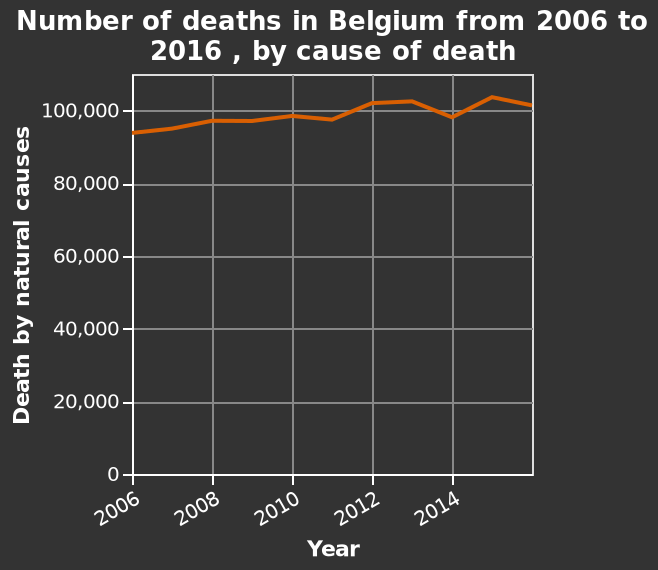<image>
Offer a thorough analysis of the image. There are approximately 100,000 deaths by natural causes in a typical year in Belgium. There appears to be a slightly increasing trend of deaths by natural causes in Belgium from 2006 to 2016. The highest number of deaths by natural causes in the years given was in 2015. The lowest number of deaths by natural causes in the years given was in 2006. Did deaths by natural causes decrease in 2010? The information provided does not mention whether deaths by natural causes decreased in 2010. What is the variable measured along the x-axis? The variable measured along the x-axis is the "Year". What is the label provided on the y-axis? The label provided on the y-axis is "Death by natural causes". In which years did the number of deaths decrease compared to the previous year?  The number of deaths showed a decrease from the previous year in 2009, 2011, and 2014. Does Belgium have approximately 10,000 deaths by natural causes in a typical year? No.There are approximately 100,000 deaths by natural causes in a typical year in Belgium. There appears to be a slightly increasing trend of deaths by natural causes in Belgium from 2006 to 2016. The highest number of deaths by natural causes in the years given was in 2015. The lowest number of deaths by natural causes in the years given was in 2006. 